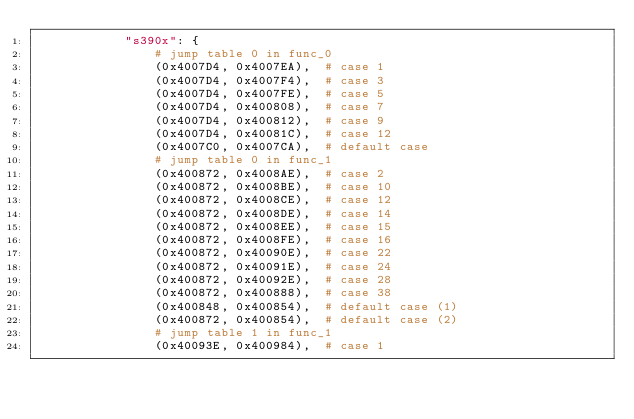Convert code to text. <code><loc_0><loc_0><loc_500><loc_500><_Python_>            "s390x": {
                # jump table 0 in func_0
                (0x4007D4, 0x4007EA),  # case 1
                (0x4007D4, 0x4007F4),  # case 3
                (0x4007D4, 0x4007FE),  # case 5
                (0x4007D4, 0x400808),  # case 7
                (0x4007D4, 0x400812),  # case 9
                (0x4007D4, 0x40081C),  # case 12
                (0x4007C0, 0x4007CA),  # default case
                # jump table 0 in func_1
                (0x400872, 0x4008AE),  # case 2
                (0x400872, 0x4008BE),  # case 10
                (0x400872, 0x4008CE),  # case 12
                (0x400872, 0x4008DE),  # case 14
                (0x400872, 0x4008EE),  # case 15
                (0x400872, 0x4008FE),  # case 16
                (0x400872, 0x40090E),  # case 22
                (0x400872, 0x40091E),  # case 24
                (0x400872, 0x40092E),  # case 28
                (0x400872, 0x400888),  # case 38
                (0x400848, 0x400854),  # default case (1)
                (0x400872, 0x400854),  # default case (2)
                # jump table 1 in func_1
                (0x40093E, 0x400984),  # case 1</code> 